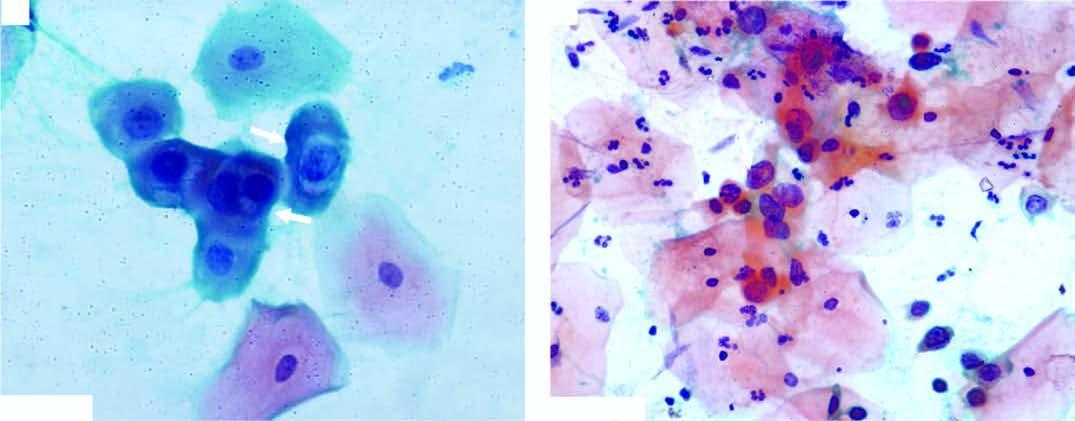does there show numerous pmns?
Answer the question using a single word or phrase. No 